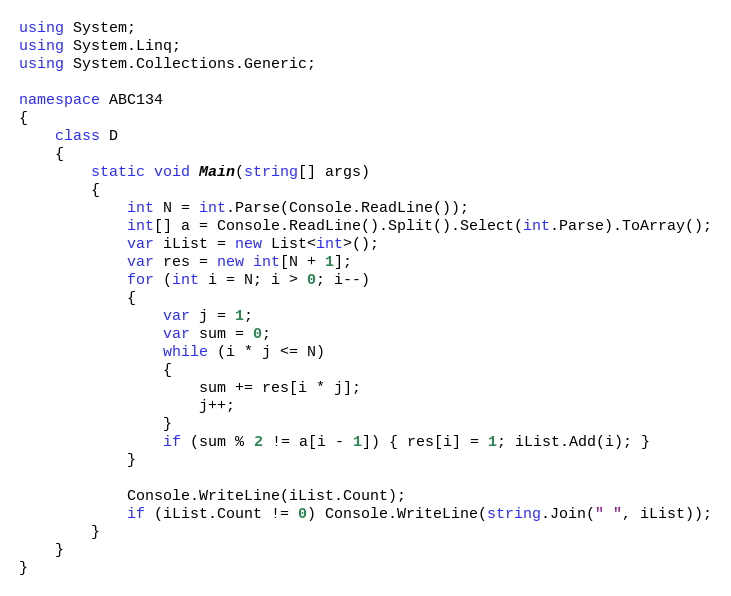<code> <loc_0><loc_0><loc_500><loc_500><_C#_>using System;
using System.Linq;
using System.Collections.Generic;

namespace ABC134
{
    class D
    {
        static void Main(string[] args)
        {
            int N = int.Parse(Console.ReadLine());
            int[] a = Console.ReadLine().Split().Select(int.Parse).ToArray();
            var iList = new List<int>();
            var res = new int[N + 1];
            for (int i = N; i > 0; i--)
            {
                var j = 1;
                var sum = 0;
                while (i * j <= N)
                {
                    sum += res[i * j];
                    j++;
                }
                if (sum % 2 != a[i - 1]) { res[i] = 1; iList.Add(i); }
            }

            Console.WriteLine(iList.Count);
            if (iList.Count != 0) Console.WriteLine(string.Join(" ", iList));
        }
    }
}</code> 